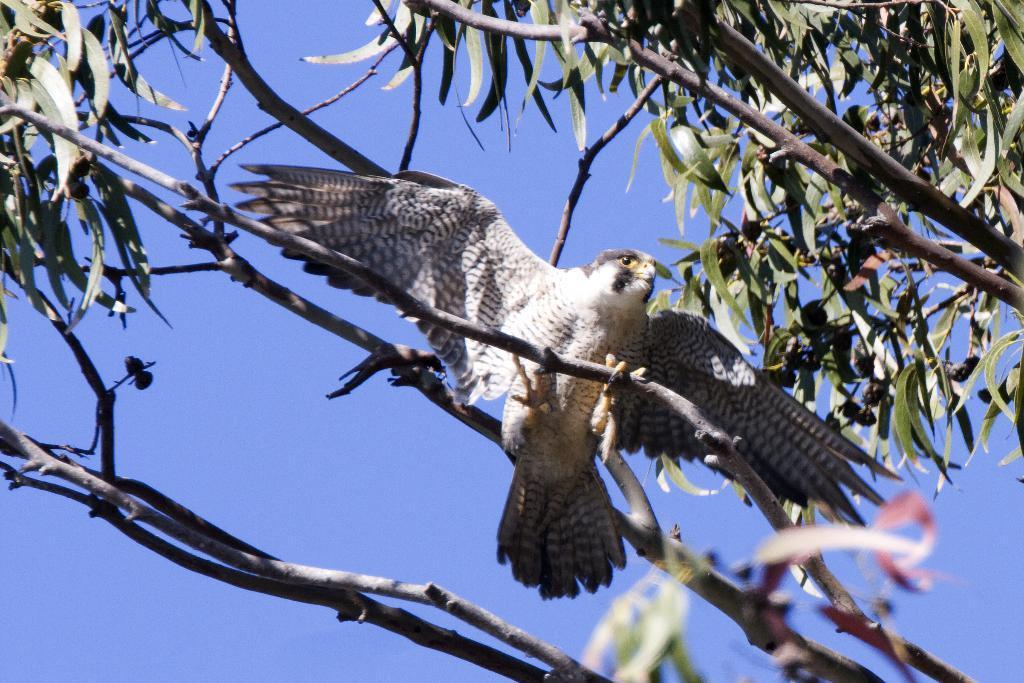Describe this image in one or two sentences. In this picture we can see a bird on a branch of a tree and in the background we can see the sky. 